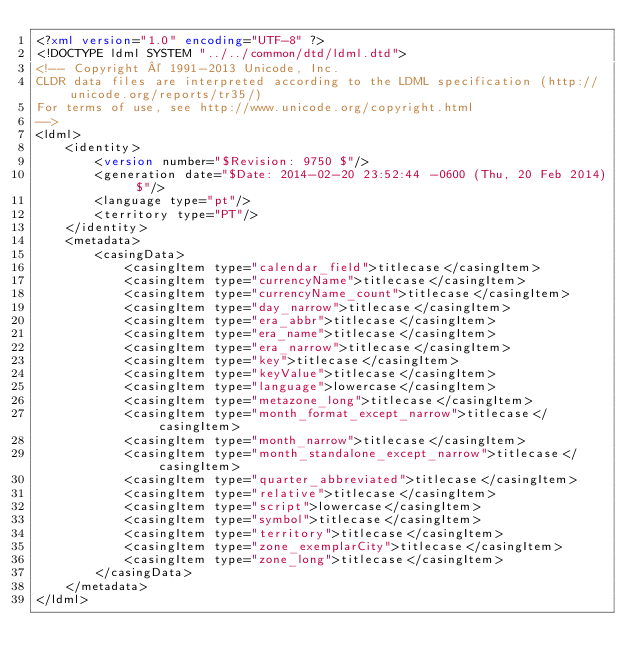Convert code to text. <code><loc_0><loc_0><loc_500><loc_500><_XML_><?xml version="1.0" encoding="UTF-8" ?>
<!DOCTYPE ldml SYSTEM "../../common/dtd/ldml.dtd">
<!-- Copyright © 1991-2013 Unicode, Inc.
CLDR data files are interpreted according to the LDML specification (http://unicode.org/reports/tr35/)
For terms of use, see http://www.unicode.org/copyright.html
-->
<ldml>
	<identity>
		<version number="$Revision: 9750 $"/>
		<generation date="$Date: 2014-02-20 23:52:44 -0600 (Thu, 20 Feb 2014) $"/>
		<language type="pt"/>
		<territory type="PT"/>
	</identity>
	<metadata>
		<casingData>
			<casingItem type="calendar_field">titlecase</casingItem>
			<casingItem type="currencyName">titlecase</casingItem>
			<casingItem type="currencyName_count">titlecase</casingItem>
			<casingItem type="day_narrow">titlecase</casingItem>
			<casingItem type="era_abbr">titlecase</casingItem>
			<casingItem type="era_name">titlecase</casingItem>
			<casingItem type="era_narrow">titlecase</casingItem>
			<casingItem type="key">titlecase</casingItem>
			<casingItem type="keyValue">titlecase</casingItem>
			<casingItem type="language">lowercase</casingItem>
			<casingItem type="metazone_long">titlecase</casingItem>
			<casingItem type="month_format_except_narrow">titlecase</casingItem>
			<casingItem type="month_narrow">titlecase</casingItem>
			<casingItem type="month_standalone_except_narrow">titlecase</casingItem>
			<casingItem type="quarter_abbreviated">titlecase</casingItem>
			<casingItem type="relative">titlecase</casingItem>
			<casingItem type="script">lowercase</casingItem>
			<casingItem type="symbol">titlecase</casingItem>
			<casingItem type="territory">titlecase</casingItem>
			<casingItem type="zone_exemplarCity">titlecase</casingItem>
			<casingItem type="zone_long">titlecase</casingItem>
		</casingData>
	</metadata>
</ldml>
</code> 